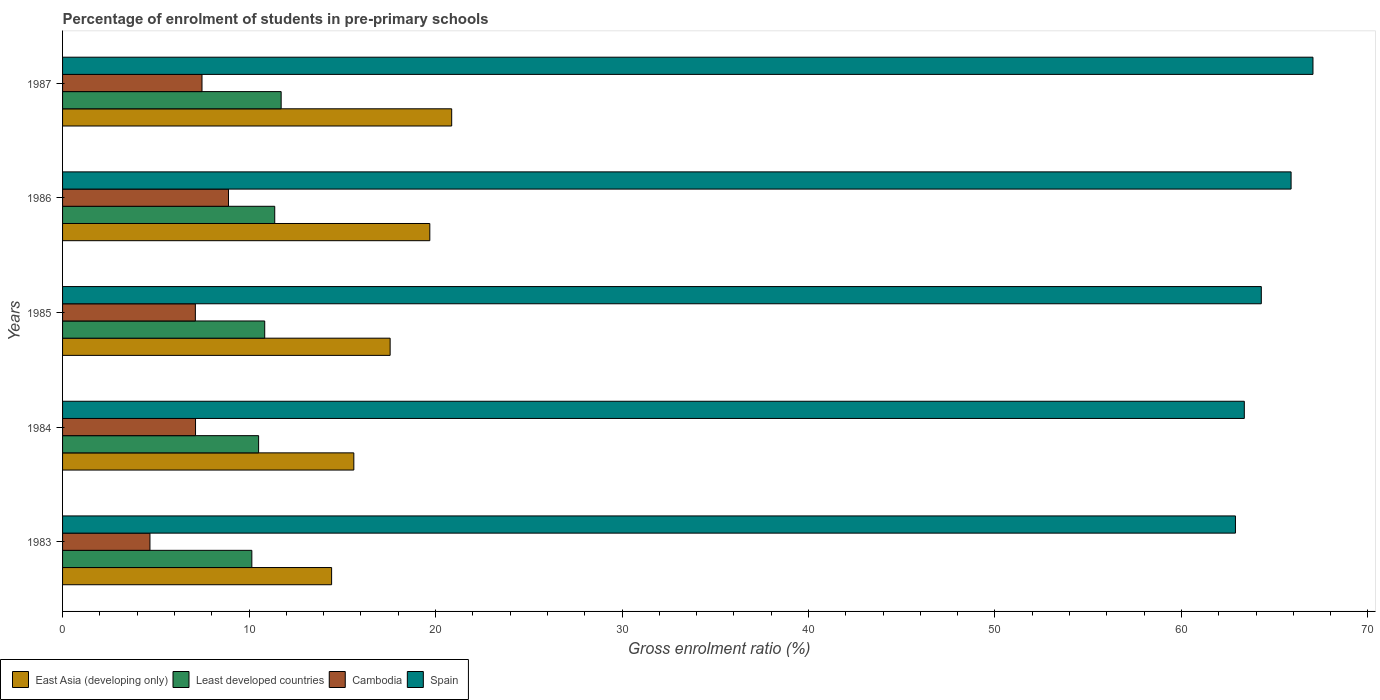How many different coloured bars are there?
Provide a short and direct response. 4. How many groups of bars are there?
Make the answer very short. 5. How many bars are there on the 1st tick from the bottom?
Your answer should be very brief. 4. In how many cases, is the number of bars for a given year not equal to the number of legend labels?
Provide a succinct answer. 0. What is the percentage of students enrolled in pre-primary schools in East Asia (developing only) in 1987?
Offer a very short reply. 20.87. Across all years, what is the maximum percentage of students enrolled in pre-primary schools in Least developed countries?
Give a very brief answer. 11.72. Across all years, what is the minimum percentage of students enrolled in pre-primary schools in Spain?
Provide a short and direct response. 62.89. In which year was the percentage of students enrolled in pre-primary schools in East Asia (developing only) maximum?
Ensure brevity in your answer.  1987. What is the total percentage of students enrolled in pre-primary schools in East Asia (developing only) in the graph?
Keep it short and to the point. 88.17. What is the difference between the percentage of students enrolled in pre-primary schools in Cambodia in 1984 and that in 1986?
Make the answer very short. -1.77. What is the difference between the percentage of students enrolled in pre-primary schools in East Asia (developing only) in 1987 and the percentage of students enrolled in pre-primary schools in Spain in 1985?
Provide a short and direct response. -43.41. What is the average percentage of students enrolled in pre-primary schools in Least developed countries per year?
Offer a terse response. 10.92. In the year 1987, what is the difference between the percentage of students enrolled in pre-primary schools in Spain and percentage of students enrolled in pre-primary schools in Least developed countries?
Your answer should be compact. 55.33. In how many years, is the percentage of students enrolled in pre-primary schools in Spain greater than 26 %?
Offer a very short reply. 5. What is the ratio of the percentage of students enrolled in pre-primary schools in Spain in 1983 to that in 1987?
Your answer should be very brief. 0.94. Is the percentage of students enrolled in pre-primary schools in East Asia (developing only) in 1984 less than that in 1986?
Keep it short and to the point. Yes. Is the difference between the percentage of students enrolled in pre-primary schools in Spain in 1983 and 1986 greater than the difference between the percentage of students enrolled in pre-primary schools in Least developed countries in 1983 and 1986?
Offer a terse response. No. What is the difference between the highest and the second highest percentage of students enrolled in pre-primary schools in East Asia (developing only)?
Keep it short and to the point. 1.17. What is the difference between the highest and the lowest percentage of students enrolled in pre-primary schools in Spain?
Make the answer very short. 4.16. In how many years, is the percentage of students enrolled in pre-primary schools in Least developed countries greater than the average percentage of students enrolled in pre-primary schools in Least developed countries taken over all years?
Provide a succinct answer. 2. Is the sum of the percentage of students enrolled in pre-primary schools in East Asia (developing only) in 1985 and 1986 greater than the maximum percentage of students enrolled in pre-primary schools in Least developed countries across all years?
Your answer should be very brief. Yes. What does the 3rd bar from the top in 1987 represents?
Provide a short and direct response. Least developed countries. Is it the case that in every year, the sum of the percentage of students enrolled in pre-primary schools in Least developed countries and percentage of students enrolled in pre-primary schools in East Asia (developing only) is greater than the percentage of students enrolled in pre-primary schools in Cambodia?
Offer a very short reply. Yes. What is the difference between two consecutive major ticks on the X-axis?
Keep it short and to the point. 10. Does the graph contain any zero values?
Your answer should be compact. No. Where does the legend appear in the graph?
Ensure brevity in your answer.  Bottom left. How are the legend labels stacked?
Your answer should be compact. Horizontal. What is the title of the graph?
Ensure brevity in your answer.  Percentage of enrolment of students in pre-primary schools. Does "Sudan" appear as one of the legend labels in the graph?
Make the answer very short. No. What is the label or title of the X-axis?
Your answer should be compact. Gross enrolment ratio (%). What is the Gross enrolment ratio (%) in East Asia (developing only) in 1983?
Keep it short and to the point. 14.43. What is the Gross enrolment ratio (%) in Least developed countries in 1983?
Your response must be concise. 10.15. What is the Gross enrolment ratio (%) in Cambodia in 1983?
Offer a very short reply. 4.69. What is the Gross enrolment ratio (%) of Spain in 1983?
Provide a succinct answer. 62.89. What is the Gross enrolment ratio (%) in East Asia (developing only) in 1984?
Give a very brief answer. 15.62. What is the Gross enrolment ratio (%) in Least developed countries in 1984?
Provide a short and direct response. 10.51. What is the Gross enrolment ratio (%) of Cambodia in 1984?
Provide a succinct answer. 7.13. What is the Gross enrolment ratio (%) in Spain in 1984?
Your response must be concise. 63.37. What is the Gross enrolment ratio (%) in East Asia (developing only) in 1985?
Keep it short and to the point. 17.57. What is the Gross enrolment ratio (%) of Least developed countries in 1985?
Your answer should be compact. 10.84. What is the Gross enrolment ratio (%) of Cambodia in 1985?
Ensure brevity in your answer.  7.12. What is the Gross enrolment ratio (%) in Spain in 1985?
Provide a short and direct response. 64.28. What is the Gross enrolment ratio (%) of East Asia (developing only) in 1986?
Offer a very short reply. 19.69. What is the Gross enrolment ratio (%) in Least developed countries in 1986?
Ensure brevity in your answer.  11.38. What is the Gross enrolment ratio (%) in Cambodia in 1986?
Give a very brief answer. 8.9. What is the Gross enrolment ratio (%) of Spain in 1986?
Ensure brevity in your answer.  65.88. What is the Gross enrolment ratio (%) of East Asia (developing only) in 1987?
Your answer should be very brief. 20.87. What is the Gross enrolment ratio (%) in Least developed countries in 1987?
Your response must be concise. 11.72. What is the Gross enrolment ratio (%) in Cambodia in 1987?
Your response must be concise. 7.48. What is the Gross enrolment ratio (%) of Spain in 1987?
Ensure brevity in your answer.  67.05. Across all years, what is the maximum Gross enrolment ratio (%) in East Asia (developing only)?
Make the answer very short. 20.87. Across all years, what is the maximum Gross enrolment ratio (%) in Least developed countries?
Your answer should be very brief. 11.72. Across all years, what is the maximum Gross enrolment ratio (%) in Cambodia?
Give a very brief answer. 8.9. Across all years, what is the maximum Gross enrolment ratio (%) in Spain?
Your answer should be very brief. 67.05. Across all years, what is the minimum Gross enrolment ratio (%) of East Asia (developing only)?
Keep it short and to the point. 14.43. Across all years, what is the minimum Gross enrolment ratio (%) in Least developed countries?
Make the answer very short. 10.15. Across all years, what is the minimum Gross enrolment ratio (%) in Cambodia?
Make the answer very short. 4.69. Across all years, what is the minimum Gross enrolment ratio (%) in Spain?
Your response must be concise. 62.89. What is the total Gross enrolment ratio (%) of East Asia (developing only) in the graph?
Your answer should be compact. 88.17. What is the total Gross enrolment ratio (%) in Least developed countries in the graph?
Make the answer very short. 54.6. What is the total Gross enrolment ratio (%) in Cambodia in the graph?
Offer a very short reply. 35.31. What is the total Gross enrolment ratio (%) in Spain in the graph?
Ensure brevity in your answer.  323.48. What is the difference between the Gross enrolment ratio (%) in East Asia (developing only) in 1983 and that in 1984?
Your response must be concise. -1.19. What is the difference between the Gross enrolment ratio (%) of Least developed countries in 1983 and that in 1984?
Provide a short and direct response. -0.36. What is the difference between the Gross enrolment ratio (%) of Cambodia in 1983 and that in 1984?
Ensure brevity in your answer.  -2.44. What is the difference between the Gross enrolment ratio (%) in Spain in 1983 and that in 1984?
Your answer should be very brief. -0.47. What is the difference between the Gross enrolment ratio (%) in East Asia (developing only) in 1983 and that in 1985?
Ensure brevity in your answer.  -3.14. What is the difference between the Gross enrolment ratio (%) in Least developed countries in 1983 and that in 1985?
Provide a short and direct response. -0.69. What is the difference between the Gross enrolment ratio (%) in Cambodia in 1983 and that in 1985?
Provide a short and direct response. -2.44. What is the difference between the Gross enrolment ratio (%) of Spain in 1983 and that in 1985?
Your response must be concise. -1.39. What is the difference between the Gross enrolment ratio (%) of East Asia (developing only) in 1983 and that in 1986?
Provide a short and direct response. -5.27. What is the difference between the Gross enrolment ratio (%) in Least developed countries in 1983 and that in 1986?
Offer a terse response. -1.23. What is the difference between the Gross enrolment ratio (%) of Cambodia in 1983 and that in 1986?
Offer a very short reply. -4.21. What is the difference between the Gross enrolment ratio (%) in Spain in 1983 and that in 1986?
Your response must be concise. -2.98. What is the difference between the Gross enrolment ratio (%) in East Asia (developing only) in 1983 and that in 1987?
Make the answer very short. -6.44. What is the difference between the Gross enrolment ratio (%) of Least developed countries in 1983 and that in 1987?
Ensure brevity in your answer.  -1.57. What is the difference between the Gross enrolment ratio (%) in Cambodia in 1983 and that in 1987?
Keep it short and to the point. -2.79. What is the difference between the Gross enrolment ratio (%) of Spain in 1983 and that in 1987?
Your answer should be very brief. -4.16. What is the difference between the Gross enrolment ratio (%) of East Asia (developing only) in 1984 and that in 1985?
Your answer should be compact. -1.95. What is the difference between the Gross enrolment ratio (%) of Least developed countries in 1984 and that in 1985?
Provide a short and direct response. -0.33. What is the difference between the Gross enrolment ratio (%) of Cambodia in 1984 and that in 1985?
Keep it short and to the point. 0.01. What is the difference between the Gross enrolment ratio (%) of Spain in 1984 and that in 1985?
Offer a terse response. -0.91. What is the difference between the Gross enrolment ratio (%) of East Asia (developing only) in 1984 and that in 1986?
Keep it short and to the point. -4.07. What is the difference between the Gross enrolment ratio (%) in Least developed countries in 1984 and that in 1986?
Offer a terse response. -0.87. What is the difference between the Gross enrolment ratio (%) in Cambodia in 1984 and that in 1986?
Offer a terse response. -1.77. What is the difference between the Gross enrolment ratio (%) of Spain in 1984 and that in 1986?
Make the answer very short. -2.51. What is the difference between the Gross enrolment ratio (%) in East Asia (developing only) in 1984 and that in 1987?
Ensure brevity in your answer.  -5.25. What is the difference between the Gross enrolment ratio (%) of Least developed countries in 1984 and that in 1987?
Your answer should be very brief. -1.21. What is the difference between the Gross enrolment ratio (%) of Cambodia in 1984 and that in 1987?
Ensure brevity in your answer.  -0.35. What is the difference between the Gross enrolment ratio (%) of Spain in 1984 and that in 1987?
Provide a short and direct response. -3.68. What is the difference between the Gross enrolment ratio (%) in East Asia (developing only) in 1985 and that in 1986?
Provide a succinct answer. -2.13. What is the difference between the Gross enrolment ratio (%) in Least developed countries in 1985 and that in 1986?
Offer a terse response. -0.54. What is the difference between the Gross enrolment ratio (%) of Cambodia in 1985 and that in 1986?
Ensure brevity in your answer.  -1.78. What is the difference between the Gross enrolment ratio (%) in Spain in 1985 and that in 1986?
Provide a succinct answer. -1.6. What is the difference between the Gross enrolment ratio (%) in East Asia (developing only) in 1985 and that in 1987?
Your response must be concise. -3.3. What is the difference between the Gross enrolment ratio (%) in Least developed countries in 1985 and that in 1987?
Ensure brevity in your answer.  -0.88. What is the difference between the Gross enrolment ratio (%) in Cambodia in 1985 and that in 1987?
Your response must be concise. -0.36. What is the difference between the Gross enrolment ratio (%) of Spain in 1985 and that in 1987?
Provide a short and direct response. -2.77. What is the difference between the Gross enrolment ratio (%) of East Asia (developing only) in 1986 and that in 1987?
Offer a very short reply. -1.17. What is the difference between the Gross enrolment ratio (%) in Least developed countries in 1986 and that in 1987?
Offer a terse response. -0.34. What is the difference between the Gross enrolment ratio (%) of Cambodia in 1986 and that in 1987?
Offer a terse response. 1.42. What is the difference between the Gross enrolment ratio (%) of Spain in 1986 and that in 1987?
Your answer should be very brief. -1.17. What is the difference between the Gross enrolment ratio (%) of East Asia (developing only) in 1983 and the Gross enrolment ratio (%) of Least developed countries in 1984?
Give a very brief answer. 3.92. What is the difference between the Gross enrolment ratio (%) of East Asia (developing only) in 1983 and the Gross enrolment ratio (%) of Cambodia in 1984?
Give a very brief answer. 7.3. What is the difference between the Gross enrolment ratio (%) in East Asia (developing only) in 1983 and the Gross enrolment ratio (%) in Spain in 1984?
Give a very brief answer. -48.94. What is the difference between the Gross enrolment ratio (%) of Least developed countries in 1983 and the Gross enrolment ratio (%) of Cambodia in 1984?
Give a very brief answer. 3.02. What is the difference between the Gross enrolment ratio (%) in Least developed countries in 1983 and the Gross enrolment ratio (%) in Spain in 1984?
Give a very brief answer. -53.22. What is the difference between the Gross enrolment ratio (%) in Cambodia in 1983 and the Gross enrolment ratio (%) in Spain in 1984?
Your response must be concise. -58.68. What is the difference between the Gross enrolment ratio (%) of East Asia (developing only) in 1983 and the Gross enrolment ratio (%) of Least developed countries in 1985?
Ensure brevity in your answer.  3.59. What is the difference between the Gross enrolment ratio (%) of East Asia (developing only) in 1983 and the Gross enrolment ratio (%) of Cambodia in 1985?
Offer a terse response. 7.31. What is the difference between the Gross enrolment ratio (%) in East Asia (developing only) in 1983 and the Gross enrolment ratio (%) in Spain in 1985?
Keep it short and to the point. -49.85. What is the difference between the Gross enrolment ratio (%) in Least developed countries in 1983 and the Gross enrolment ratio (%) in Cambodia in 1985?
Offer a terse response. 3.03. What is the difference between the Gross enrolment ratio (%) of Least developed countries in 1983 and the Gross enrolment ratio (%) of Spain in 1985?
Offer a terse response. -54.13. What is the difference between the Gross enrolment ratio (%) of Cambodia in 1983 and the Gross enrolment ratio (%) of Spain in 1985?
Make the answer very short. -59.6. What is the difference between the Gross enrolment ratio (%) in East Asia (developing only) in 1983 and the Gross enrolment ratio (%) in Least developed countries in 1986?
Offer a very short reply. 3.05. What is the difference between the Gross enrolment ratio (%) in East Asia (developing only) in 1983 and the Gross enrolment ratio (%) in Cambodia in 1986?
Ensure brevity in your answer.  5.53. What is the difference between the Gross enrolment ratio (%) in East Asia (developing only) in 1983 and the Gross enrolment ratio (%) in Spain in 1986?
Offer a terse response. -51.45. What is the difference between the Gross enrolment ratio (%) in Least developed countries in 1983 and the Gross enrolment ratio (%) in Cambodia in 1986?
Provide a succinct answer. 1.25. What is the difference between the Gross enrolment ratio (%) in Least developed countries in 1983 and the Gross enrolment ratio (%) in Spain in 1986?
Your answer should be very brief. -55.73. What is the difference between the Gross enrolment ratio (%) of Cambodia in 1983 and the Gross enrolment ratio (%) of Spain in 1986?
Offer a very short reply. -61.19. What is the difference between the Gross enrolment ratio (%) of East Asia (developing only) in 1983 and the Gross enrolment ratio (%) of Least developed countries in 1987?
Your answer should be very brief. 2.71. What is the difference between the Gross enrolment ratio (%) of East Asia (developing only) in 1983 and the Gross enrolment ratio (%) of Cambodia in 1987?
Your answer should be compact. 6.95. What is the difference between the Gross enrolment ratio (%) in East Asia (developing only) in 1983 and the Gross enrolment ratio (%) in Spain in 1987?
Keep it short and to the point. -52.62. What is the difference between the Gross enrolment ratio (%) in Least developed countries in 1983 and the Gross enrolment ratio (%) in Cambodia in 1987?
Offer a very short reply. 2.67. What is the difference between the Gross enrolment ratio (%) of Least developed countries in 1983 and the Gross enrolment ratio (%) of Spain in 1987?
Your response must be concise. -56.9. What is the difference between the Gross enrolment ratio (%) in Cambodia in 1983 and the Gross enrolment ratio (%) in Spain in 1987?
Offer a terse response. -62.37. What is the difference between the Gross enrolment ratio (%) in East Asia (developing only) in 1984 and the Gross enrolment ratio (%) in Least developed countries in 1985?
Your answer should be compact. 4.78. What is the difference between the Gross enrolment ratio (%) in East Asia (developing only) in 1984 and the Gross enrolment ratio (%) in Cambodia in 1985?
Provide a short and direct response. 8.5. What is the difference between the Gross enrolment ratio (%) in East Asia (developing only) in 1984 and the Gross enrolment ratio (%) in Spain in 1985?
Your response must be concise. -48.66. What is the difference between the Gross enrolment ratio (%) in Least developed countries in 1984 and the Gross enrolment ratio (%) in Cambodia in 1985?
Keep it short and to the point. 3.39. What is the difference between the Gross enrolment ratio (%) of Least developed countries in 1984 and the Gross enrolment ratio (%) of Spain in 1985?
Offer a terse response. -53.77. What is the difference between the Gross enrolment ratio (%) of Cambodia in 1984 and the Gross enrolment ratio (%) of Spain in 1985?
Keep it short and to the point. -57.15. What is the difference between the Gross enrolment ratio (%) of East Asia (developing only) in 1984 and the Gross enrolment ratio (%) of Least developed countries in 1986?
Your response must be concise. 4.24. What is the difference between the Gross enrolment ratio (%) in East Asia (developing only) in 1984 and the Gross enrolment ratio (%) in Cambodia in 1986?
Give a very brief answer. 6.72. What is the difference between the Gross enrolment ratio (%) of East Asia (developing only) in 1984 and the Gross enrolment ratio (%) of Spain in 1986?
Give a very brief answer. -50.26. What is the difference between the Gross enrolment ratio (%) in Least developed countries in 1984 and the Gross enrolment ratio (%) in Cambodia in 1986?
Provide a succinct answer. 1.61. What is the difference between the Gross enrolment ratio (%) of Least developed countries in 1984 and the Gross enrolment ratio (%) of Spain in 1986?
Offer a terse response. -55.37. What is the difference between the Gross enrolment ratio (%) of Cambodia in 1984 and the Gross enrolment ratio (%) of Spain in 1986?
Offer a terse response. -58.75. What is the difference between the Gross enrolment ratio (%) of East Asia (developing only) in 1984 and the Gross enrolment ratio (%) of Least developed countries in 1987?
Provide a short and direct response. 3.9. What is the difference between the Gross enrolment ratio (%) of East Asia (developing only) in 1984 and the Gross enrolment ratio (%) of Cambodia in 1987?
Keep it short and to the point. 8.14. What is the difference between the Gross enrolment ratio (%) of East Asia (developing only) in 1984 and the Gross enrolment ratio (%) of Spain in 1987?
Your response must be concise. -51.43. What is the difference between the Gross enrolment ratio (%) of Least developed countries in 1984 and the Gross enrolment ratio (%) of Cambodia in 1987?
Provide a short and direct response. 3.04. What is the difference between the Gross enrolment ratio (%) in Least developed countries in 1984 and the Gross enrolment ratio (%) in Spain in 1987?
Offer a very short reply. -56.54. What is the difference between the Gross enrolment ratio (%) in Cambodia in 1984 and the Gross enrolment ratio (%) in Spain in 1987?
Offer a very short reply. -59.92. What is the difference between the Gross enrolment ratio (%) of East Asia (developing only) in 1985 and the Gross enrolment ratio (%) of Least developed countries in 1986?
Ensure brevity in your answer.  6.19. What is the difference between the Gross enrolment ratio (%) of East Asia (developing only) in 1985 and the Gross enrolment ratio (%) of Cambodia in 1986?
Provide a succinct answer. 8.67. What is the difference between the Gross enrolment ratio (%) of East Asia (developing only) in 1985 and the Gross enrolment ratio (%) of Spain in 1986?
Ensure brevity in your answer.  -48.31. What is the difference between the Gross enrolment ratio (%) in Least developed countries in 1985 and the Gross enrolment ratio (%) in Cambodia in 1986?
Give a very brief answer. 1.94. What is the difference between the Gross enrolment ratio (%) of Least developed countries in 1985 and the Gross enrolment ratio (%) of Spain in 1986?
Give a very brief answer. -55.04. What is the difference between the Gross enrolment ratio (%) in Cambodia in 1985 and the Gross enrolment ratio (%) in Spain in 1986?
Offer a terse response. -58.76. What is the difference between the Gross enrolment ratio (%) of East Asia (developing only) in 1985 and the Gross enrolment ratio (%) of Least developed countries in 1987?
Offer a terse response. 5.84. What is the difference between the Gross enrolment ratio (%) in East Asia (developing only) in 1985 and the Gross enrolment ratio (%) in Cambodia in 1987?
Provide a succinct answer. 10.09. What is the difference between the Gross enrolment ratio (%) of East Asia (developing only) in 1985 and the Gross enrolment ratio (%) of Spain in 1987?
Your answer should be very brief. -49.49. What is the difference between the Gross enrolment ratio (%) of Least developed countries in 1985 and the Gross enrolment ratio (%) of Cambodia in 1987?
Provide a short and direct response. 3.36. What is the difference between the Gross enrolment ratio (%) of Least developed countries in 1985 and the Gross enrolment ratio (%) of Spain in 1987?
Provide a short and direct response. -56.21. What is the difference between the Gross enrolment ratio (%) of Cambodia in 1985 and the Gross enrolment ratio (%) of Spain in 1987?
Make the answer very short. -59.93. What is the difference between the Gross enrolment ratio (%) of East Asia (developing only) in 1986 and the Gross enrolment ratio (%) of Least developed countries in 1987?
Your answer should be very brief. 7.97. What is the difference between the Gross enrolment ratio (%) in East Asia (developing only) in 1986 and the Gross enrolment ratio (%) in Cambodia in 1987?
Provide a succinct answer. 12.22. What is the difference between the Gross enrolment ratio (%) of East Asia (developing only) in 1986 and the Gross enrolment ratio (%) of Spain in 1987?
Your answer should be compact. -47.36. What is the difference between the Gross enrolment ratio (%) in Least developed countries in 1986 and the Gross enrolment ratio (%) in Cambodia in 1987?
Provide a succinct answer. 3.9. What is the difference between the Gross enrolment ratio (%) in Least developed countries in 1986 and the Gross enrolment ratio (%) in Spain in 1987?
Your answer should be compact. -55.67. What is the difference between the Gross enrolment ratio (%) of Cambodia in 1986 and the Gross enrolment ratio (%) of Spain in 1987?
Make the answer very short. -58.15. What is the average Gross enrolment ratio (%) of East Asia (developing only) per year?
Offer a terse response. 17.63. What is the average Gross enrolment ratio (%) in Least developed countries per year?
Provide a short and direct response. 10.92. What is the average Gross enrolment ratio (%) in Cambodia per year?
Offer a very short reply. 7.06. What is the average Gross enrolment ratio (%) of Spain per year?
Make the answer very short. 64.69. In the year 1983, what is the difference between the Gross enrolment ratio (%) of East Asia (developing only) and Gross enrolment ratio (%) of Least developed countries?
Offer a terse response. 4.28. In the year 1983, what is the difference between the Gross enrolment ratio (%) of East Asia (developing only) and Gross enrolment ratio (%) of Cambodia?
Offer a terse response. 9.74. In the year 1983, what is the difference between the Gross enrolment ratio (%) of East Asia (developing only) and Gross enrolment ratio (%) of Spain?
Keep it short and to the point. -48.47. In the year 1983, what is the difference between the Gross enrolment ratio (%) of Least developed countries and Gross enrolment ratio (%) of Cambodia?
Offer a terse response. 5.46. In the year 1983, what is the difference between the Gross enrolment ratio (%) in Least developed countries and Gross enrolment ratio (%) in Spain?
Give a very brief answer. -52.75. In the year 1983, what is the difference between the Gross enrolment ratio (%) of Cambodia and Gross enrolment ratio (%) of Spain?
Keep it short and to the point. -58.21. In the year 1984, what is the difference between the Gross enrolment ratio (%) of East Asia (developing only) and Gross enrolment ratio (%) of Least developed countries?
Your response must be concise. 5.11. In the year 1984, what is the difference between the Gross enrolment ratio (%) in East Asia (developing only) and Gross enrolment ratio (%) in Cambodia?
Offer a terse response. 8.49. In the year 1984, what is the difference between the Gross enrolment ratio (%) in East Asia (developing only) and Gross enrolment ratio (%) in Spain?
Provide a succinct answer. -47.75. In the year 1984, what is the difference between the Gross enrolment ratio (%) of Least developed countries and Gross enrolment ratio (%) of Cambodia?
Offer a very short reply. 3.38. In the year 1984, what is the difference between the Gross enrolment ratio (%) in Least developed countries and Gross enrolment ratio (%) in Spain?
Your answer should be compact. -52.86. In the year 1984, what is the difference between the Gross enrolment ratio (%) of Cambodia and Gross enrolment ratio (%) of Spain?
Your answer should be very brief. -56.24. In the year 1985, what is the difference between the Gross enrolment ratio (%) in East Asia (developing only) and Gross enrolment ratio (%) in Least developed countries?
Provide a succinct answer. 6.73. In the year 1985, what is the difference between the Gross enrolment ratio (%) in East Asia (developing only) and Gross enrolment ratio (%) in Cambodia?
Keep it short and to the point. 10.44. In the year 1985, what is the difference between the Gross enrolment ratio (%) of East Asia (developing only) and Gross enrolment ratio (%) of Spain?
Keep it short and to the point. -46.72. In the year 1985, what is the difference between the Gross enrolment ratio (%) of Least developed countries and Gross enrolment ratio (%) of Cambodia?
Give a very brief answer. 3.72. In the year 1985, what is the difference between the Gross enrolment ratio (%) of Least developed countries and Gross enrolment ratio (%) of Spain?
Your response must be concise. -53.44. In the year 1985, what is the difference between the Gross enrolment ratio (%) of Cambodia and Gross enrolment ratio (%) of Spain?
Offer a very short reply. -57.16. In the year 1986, what is the difference between the Gross enrolment ratio (%) of East Asia (developing only) and Gross enrolment ratio (%) of Least developed countries?
Ensure brevity in your answer.  8.32. In the year 1986, what is the difference between the Gross enrolment ratio (%) in East Asia (developing only) and Gross enrolment ratio (%) in Cambodia?
Your answer should be very brief. 10.79. In the year 1986, what is the difference between the Gross enrolment ratio (%) of East Asia (developing only) and Gross enrolment ratio (%) of Spain?
Keep it short and to the point. -46.18. In the year 1986, what is the difference between the Gross enrolment ratio (%) in Least developed countries and Gross enrolment ratio (%) in Cambodia?
Ensure brevity in your answer.  2.48. In the year 1986, what is the difference between the Gross enrolment ratio (%) of Least developed countries and Gross enrolment ratio (%) of Spain?
Offer a terse response. -54.5. In the year 1986, what is the difference between the Gross enrolment ratio (%) of Cambodia and Gross enrolment ratio (%) of Spain?
Offer a terse response. -56.98. In the year 1987, what is the difference between the Gross enrolment ratio (%) of East Asia (developing only) and Gross enrolment ratio (%) of Least developed countries?
Offer a very short reply. 9.15. In the year 1987, what is the difference between the Gross enrolment ratio (%) of East Asia (developing only) and Gross enrolment ratio (%) of Cambodia?
Keep it short and to the point. 13.39. In the year 1987, what is the difference between the Gross enrolment ratio (%) in East Asia (developing only) and Gross enrolment ratio (%) in Spain?
Your answer should be compact. -46.18. In the year 1987, what is the difference between the Gross enrolment ratio (%) in Least developed countries and Gross enrolment ratio (%) in Cambodia?
Your answer should be very brief. 4.24. In the year 1987, what is the difference between the Gross enrolment ratio (%) in Least developed countries and Gross enrolment ratio (%) in Spain?
Your answer should be very brief. -55.33. In the year 1987, what is the difference between the Gross enrolment ratio (%) in Cambodia and Gross enrolment ratio (%) in Spain?
Give a very brief answer. -59.57. What is the ratio of the Gross enrolment ratio (%) in East Asia (developing only) in 1983 to that in 1984?
Provide a short and direct response. 0.92. What is the ratio of the Gross enrolment ratio (%) of Least developed countries in 1983 to that in 1984?
Ensure brevity in your answer.  0.97. What is the ratio of the Gross enrolment ratio (%) in Cambodia in 1983 to that in 1984?
Keep it short and to the point. 0.66. What is the ratio of the Gross enrolment ratio (%) in East Asia (developing only) in 1983 to that in 1985?
Provide a short and direct response. 0.82. What is the ratio of the Gross enrolment ratio (%) of Least developed countries in 1983 to that in 1985?
Ensure brevity in your answer.  0.94. What is the ratio of the Gross enrolment ratio (%) of Cambodia in 1983 to that in 1985?
Keep it short and to the point. 0.66. What is the ratio of the Gross enrolment ratio (%) in Spain in 1983 to that in 1985?
Keep it short and to the point. 0.98. What is the ratio of the Gross enrolment ratio (%) of East Asia (developing only) in 1983 to that in 1986?
Make the answer very short. 0.73. What is the ratio of the Gross enrolment ratio (%) in Least developed countries in 1983 to that in 1986?
Give a very brief answer. 0.89. What is the ratio of the Gross enrolment ratio (%) in Cambodia in 1983 to that in 1986?
Give a very brief answer. 0.53. What is the ratio of the Gross enrolment ratio (%) of Spain in 1983 to that in 1986?
Keep it short and to the point. 0.95. What is the ratio of the Gross enrolment ratio (%) of East Asia (developing only) in 1983 to that in 1987?
Ensure brevity in your answer.  0.69. What is the ratio of the Gross enrolment ratio (%) of Least developed countries in 1983 to that in 1987?
Your answer should be compact. 0.87. What is the ratio of the Gross enrolment ratio (%) in Cambodia in 1983 to that in 1987?
Keep it short and to the point. 0.63. What is the ratio of the Gross enrolment ratio (%) in Spain in 1983 to that in 1987?
Offer a very short reply. 0.94. What is the ratio of the Gross enrolment ratio (%) in East Asia (developing only) in 1984 to that in 1985?
Keep it short and to the point. 0.89. What is the ratio of the Gross enrolment ratio (%) in Least developed countries in 1984 to that in 1985?
Offer a very short reply. 0.97. What is the ratio of the Gross enrolment ratio (%) of Cambodia in 1984 to that in 1985?
Give a very brief answer. 1. What is the ratio of the Gross enrolment ratio (%) of Spain in 1984 to that in 1985?
Ensure brevity in your answer.  0.99. What is the ratio of the Gross enrolment ratio (%) in East Asia (developing only) in 1984 to that in 1986?
Offer a very short reply. 0.79. What is the ratio of the Gross enrolment ratio (%) in Least developed countries in 1984 to that in 1986?
Offer a terse response. 0.92. What is the ratio of the Gross enrolment ratio (%) in Cambodia in 1984 to that in 1986?
Provide a short and direct response. 0.8. What is the ratio of the Gross enrolment ratio (%) in Spain in 1984 to that in 1986?
Give a very brief answer. 0.96. What is the ratio of the Gross enrolment ratio (%) of East Asia (developing only) in 1984 to that in 1987?
Give a very brief answer. 0.75. What is the ratio of the Gross enrolment ratio (%) in Least developed countries in 1984 to that in 1987?
Offer a very short reply. 0.9. What is the ratio of the Gross enrolment ratio (%) of Cambodia in 1984 to that in 1987?
Provide a succinct answer. 0.95. What is the ratio of the Gross enrolment ratio (%) in Spain in 1984 to that in 1987?
Offer a very short reply. 0.95. What is the ratio of the Gross enrolment ratio (%) of East Asia (developing only) in 1985 to that in 1986?
Make the answer very short. 0.89. What is the ratio of the Gross enrolment ratio (%) in Least developed countries in 1985 to that in 1986?
Offer a terse response. 0.95. What is the ratio of the Gross enrolment ratio (%) in Cambodia in 1985 to that in 1986?
Make the answer very short. 0.8. What is the ratio of the Gross enrolment ratio (%) in Spain in 1985 to that in 1986?
Offer a terse response. 0.98. What is the ratio of the Gross enrolment ratio (%) of East Asia (developing only) in 1985 to that in 1987?
Give a very brief answer. 0.84. What is the ratio of the Gross enrolment ratio (%) in Least developed countries in 1985 to that in 1987?
Offer a terse response. 0.92. What is the ratio of the Gross enrolment ratio (%) of Cambodia in 1985 to that in 1987?
Offer a terse response. 0.95. What is the ratio of the Gross enrolment ratio (%) in Spain in 1985 to that in 1987?
Your response must be concise. 0.96. What is the ratio of the Gross enrolment ratio (%) of East Asia (developing only) in 1986 to that in 1987?
Make the answer very short. 0.94. What is the ratio of the Gross enrolment ratio (%) of Least developed countries in 1986 to that in 1987?
Your response must be concise. 0.97. What is the ratio of the Gross enrolment ratio (%) in Cambodia in 1986 to that in 1987?
Your answer should be very brief. 1.19. What is the ratio of the Gross enrolment ratio (%) in Spain in 1986 to that in 1987?
Keep it short and to the point. 0.98. What is the difference between the highest and the second highest Gross enrolment ratio (%) in East Asia (developing only)?
Offer a terse response. 1.17. What is the difference between the highest and the second highest Gross enrolment ratio (%) in Least developed countries?
Keep it short and to the point. 0.34. What is the difference between the highest and the second highest Gross enrolment ratio (%) of Cambodia?
Provide a short and direct response. 1.42. What is the difference between the highest and the second highest Gross enrolment ratio (%) in Spain?
Make the answer very short. 1.17. What is the difference between the highest and the lowest Gross enrolment ratio (%) in East Asia (developing only)?
Your answer should be compact. 6.44. What is the difference between the highest and the lowest Gross enrolment ratio (%) in Least developed countries?
Keep it short and to the point. 1.57. What is the difference between the highest and the lowest Gross enrolment ratio (%) in Cambodia?
Provide a succinct answer. 4.21. What is the difference between the highest and the lowest Gross enrolment ratio (%) of Spain?
Make the answer very short. 4.16. 